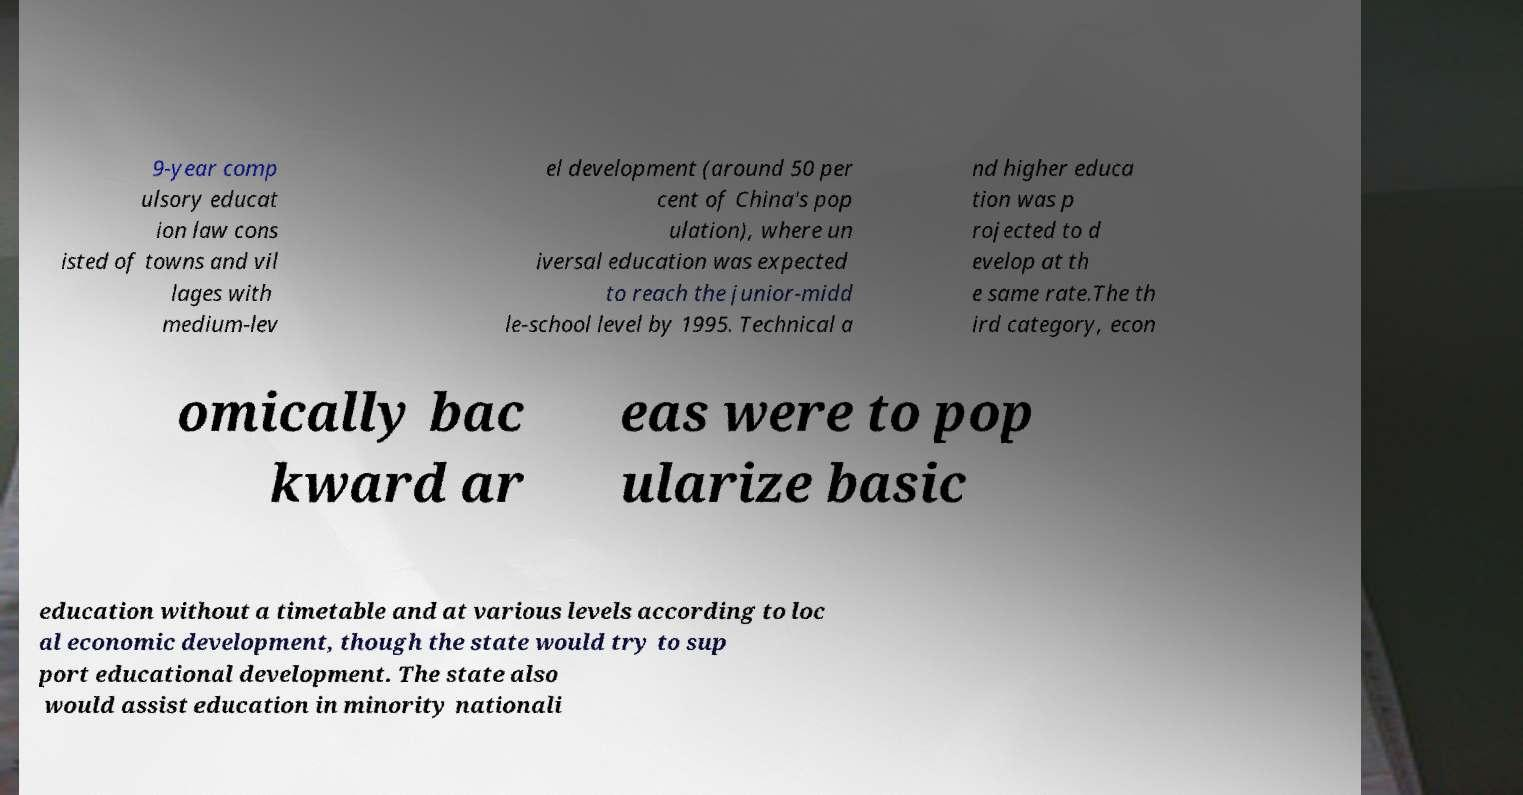There's text embedded in this image that I need extracted. Can you transcribe it verbatim? 9-year comp ulsory educat ion law cons isted of towns and vil lages with medium-lev el development (around 50 per cent of China's pop ulation), where un iversal education was expected to reach the junior-midd le-school level by 1995. Technical a nd higher educa tion was p rojected to d evelop at th e same rate.The th ird category, econ omically bac kward ar eas were to pop ularize basic education without a timetable and at various levels according to loc al economic development, though the state would try to sup port educational development. The state also would assist education in minority nationali 